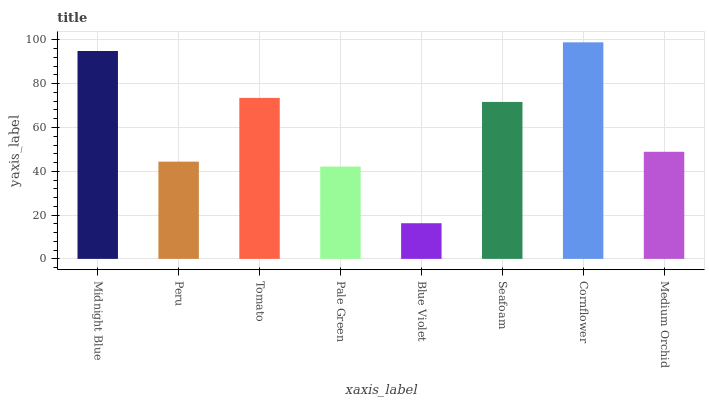Is Blue Violet the minimum?
Answer yes or no. Yes. Is Cornflower the maximum?
Answer yes or no. Yes. Is Peru the minimum?
Answer yes or no. No. Is Peru the maximum?
Answer yes or no. No. Is Midnight Blue greater than Peru?
Answer yes or no. Yes. Is Peru less than Midnight Blue?
Answer yes or no. Yes. Is Peru greater than Midnight Blue?
Answer yes or no. No. Is Midnight Blue less than Peru?
Answer yes or no. No. Is Seafoam the high median?
Answer yes or no. Yes. Is Medium Orchid the low median?
Answer yes or no. Yes. Is Midnight Blue the high median?
Answer yes or no. No. Is Midnight Blue the low median?
Answer yes or no. No. 